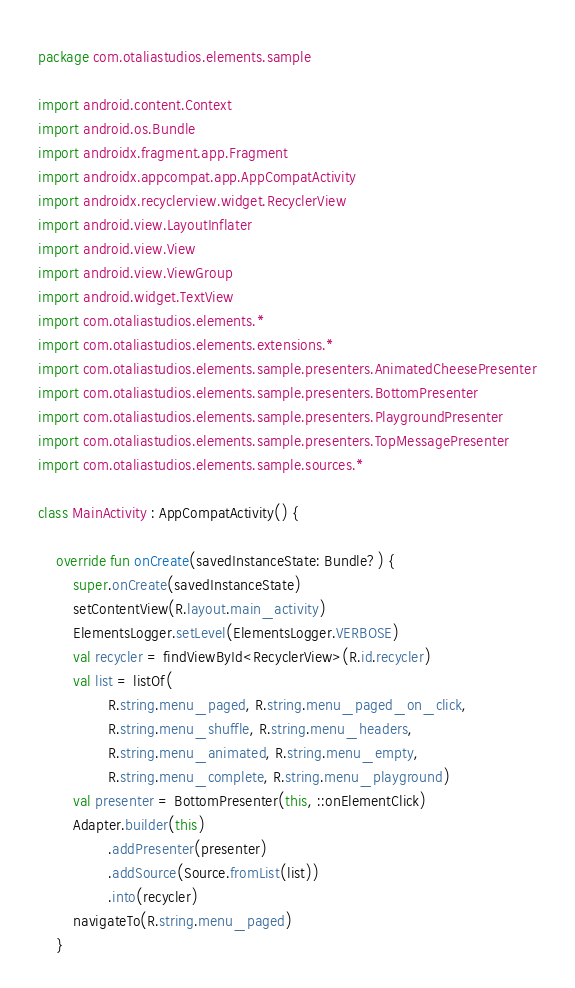Convert code to text. <code><loc_0><loc_0><loc_500><loc_500><_Kotlin_>package com.otaliastudios.elements.sample

import android.content.Context
import android.os.Bundle
import androidx.fragment.app.Fragment
import androidx.appcompat.app.AppCompatActivity
import androidx.recyclerview.widget.RecyclerView
import android.view.LayoutInflater
import android.view.View
import android.view.ViewGroup
import android.widget.TextView
import com.otaliastudios.elements.*
import com.otaliastudios.elements.extensions.*
import com.otaliastudios.elements.sample.presenters.AnimatedCheesePresenter
import com.otaliastudios.elements.sample.presenters.BottomPresenter
import com.otaliastudios.elements.sample.presenters.PlaygroundPresenter
import com.otaliastudios.elements.sample.presenters.TopMessagePresenter
import com.otaliastudios.elements.sample.sources.*

class MainActivity : AppCompatActivity() {

    override fun onCreate(savedInstanceState: Bundle?) {
        super.onCreate(savedInstanceState)
        setContentView(R.layout.main_activity)
        ElementsLogger.setLevel(ElementsLogger.VERBOSE)
        val recycler = findViewById<RecyclerView>(R.id.recycler)
        val list = listOf(
                R.string.menu_paged, R.string.menu_paged_on_click,
                R.string.menu_shuffle, R.string.menu_headers,
                R.string.menu_animated, R.string.menu_empty,
                R.string.menu_complete, R.string.menu_playground)
        val presenter = BottomPresenter(this, ::onElementClick)
        Adapter.builder(this)
                .addPresenter(presenter)
                .addSource(Source.fromList(list))
                .into(recycler)
        navigateTo(R.string.menu_paged)
    }
</code> 